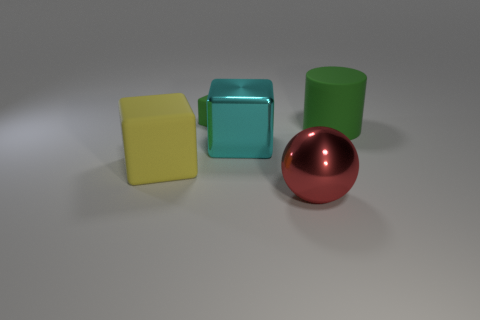Is there any other thing that has the same size as the green matte block?
Ensure brevity in your answer.  No. Is the number of green matte cylinders that are on the left side of the matte cylinder greater than the number of tiny green blocks that are behind the small rubber cube?
Provide a short and direct response. No. There is a object behind the large thing that is on the right side of the object that is in front of the large rubber cube; what color is it?
Make the answer very short. Green. Does the matte cube right of the yellow matte block have the same color as the large cylinder?
Your response must be concise. Yes. How many other objects are there of the same color as the big ball?
Provide a succinct answer. 0. How many objects are either rubber blocks or spheres?
Ensure brevity in your answer.  3. What number of things are either blocks or green things that are right of the large metal cube?
Give a very brief answer. 4. Does the large cylinder have the same material as the big yellow object?
Offer a terse response. Yes. How many other things are made of the same material as the red ball?
Your answer should be very brief. 1. Are there more tiny cyan matte things than big rubber cylinders?
Your answer should be compact. No. 